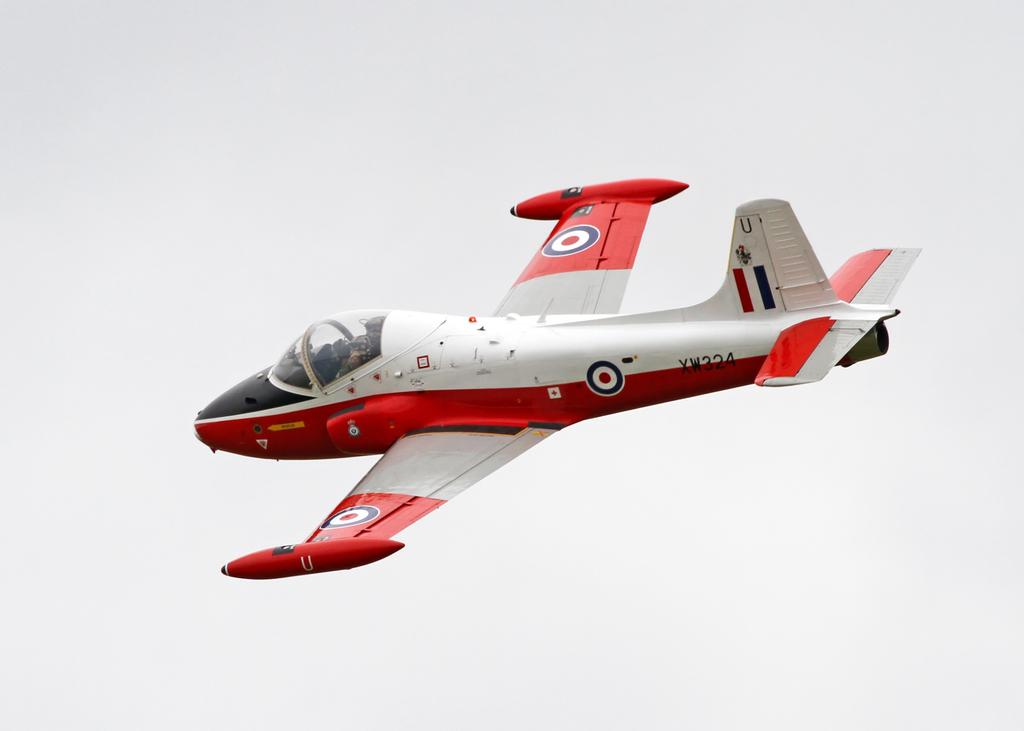What is the plane number?
Offer a terse response. Xw324. What is the model number?
Keep it short and to the point. Xw324. 